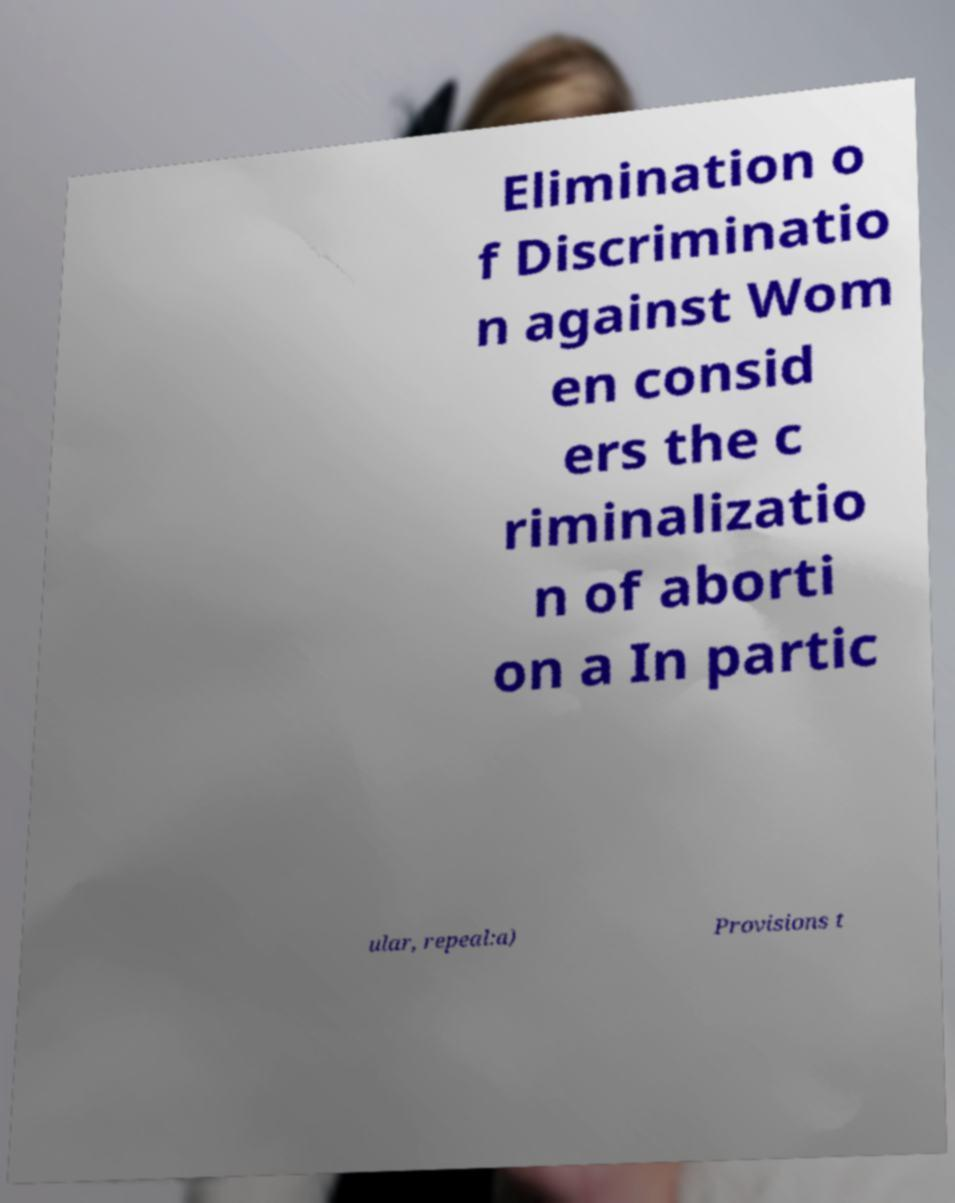What messages or text are displayed in this image? I need them in a readable, typed format. Elimination o f Discriminatio n against Wom en consid ers the c riminalizatio n of aborti on a In partic ular, repeal:a) Provisions t 